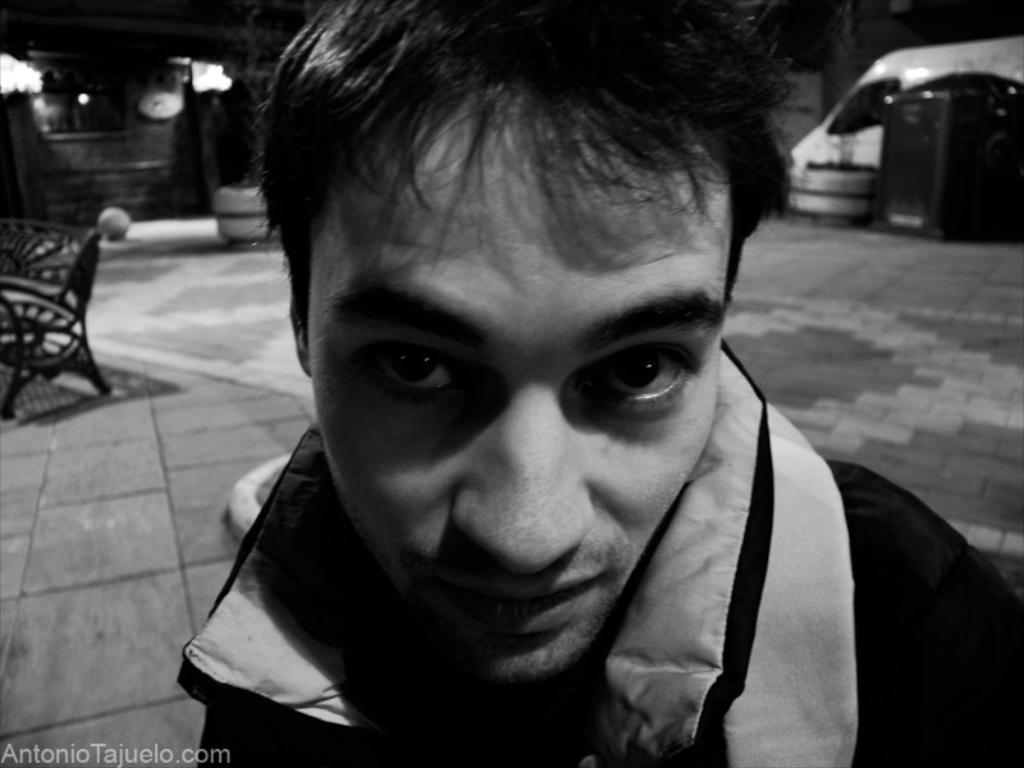In one or two sentences, can you explain what this image depicts? It is a black and white image. In this picture, we can see a person is watching. Background we can see a blur view. Here there is a bench, path and few objects. On the left side bottom corner, there is a watermark in the image. 